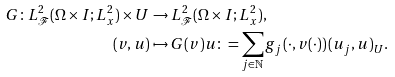Convert formula to latex. <formula><loc_0><loc_0><loc_500><loc_500>G \colon L ^ { 2 } _ { \mathcal { F } } ( \Omega \times I ; L ^ { 2 } _ { x } ) \times U & \to L ^ { 2 } _ { \mathcal { F } } ( \Omega \times I ; L ^ { 2 } _ { x } ) , \\ ( v , u ) & \mapsto G ( v ) u \colon = \sum _ { j \in \mathbb { N } } g _ { j } \left ( \cdot , v ( \cdot ) \right ) ( u _ { j } , u ) _ { U } .</formula> 